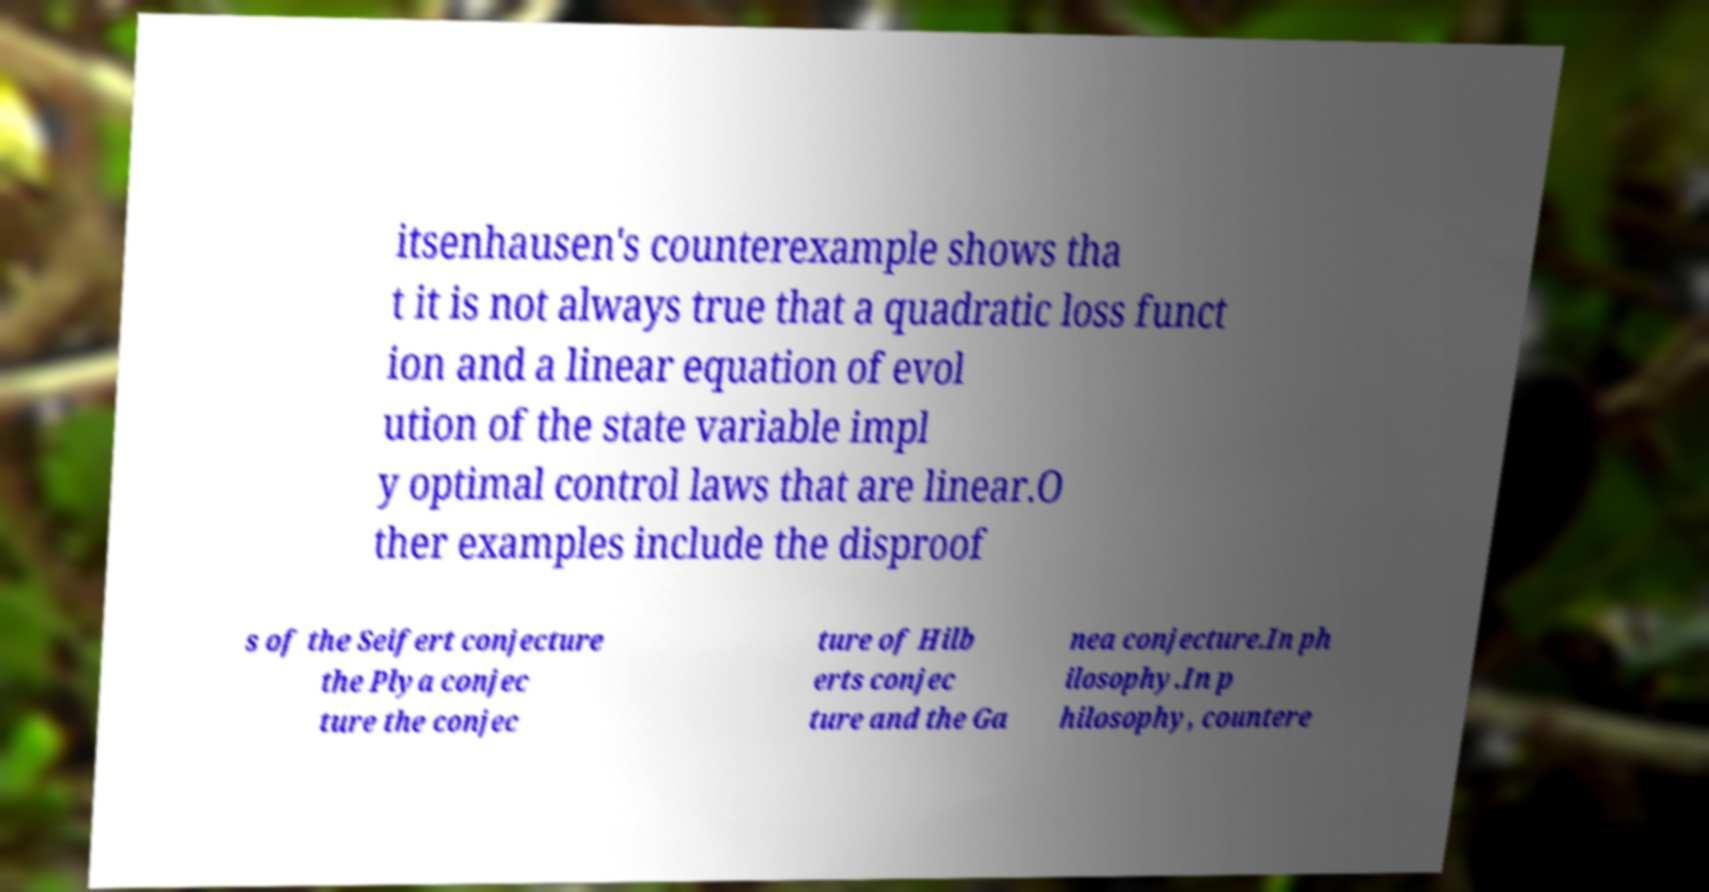Could you extract and type out the text from this image? itsenhausen's counterexample shows tha t it is not always true that a quadratic loss funct ion and a linear equation of evol ution of the state variable impl y optimal control laws that are linear.O ther examples include the disproof s of the Seifert conjecture the Plya conjec ture the conjec ture of Hilb erts conjec ture and the Ga nea conjecture.In ph ilosophy.In p hilosophy, countere 